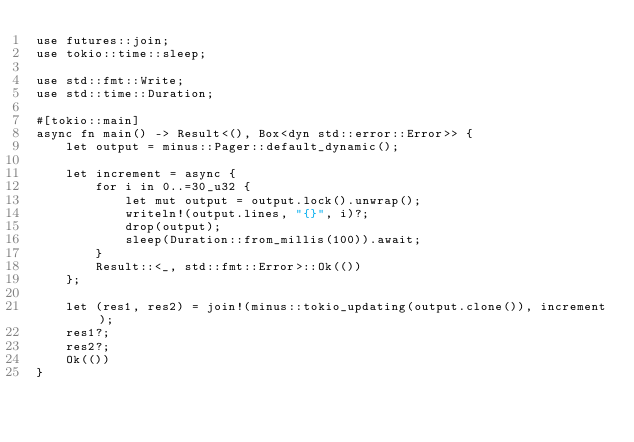Convert code to text. <code><loc_0><loc_0><loc_500><loc_500><_Rust_>use futures::join;
use tokio::time::sleep;

use std::fmt::Write;
use std::time::Duration;

#[tokio::main]
async fn main() -> Result<(), Box<dyn std::error::Error>> {
    let output = minus::Pager::default_dynamic();

    let increment = async {
        for i in 0..=30_u32 {
            let mut output = output.lock().unwrap();
            writeln!(output.lines, "{}", i)?;
            drop(output);
            sleep(Duration::from_millis(100)).await;
        }
        Result::<_, std::fmt::Error>::Ok(())
    };

    let (res1, res2) = join!(minus::tokio_updating(output.clone()), increment);
    res1?;
    res2?;
    Ok(())
}
</code> 